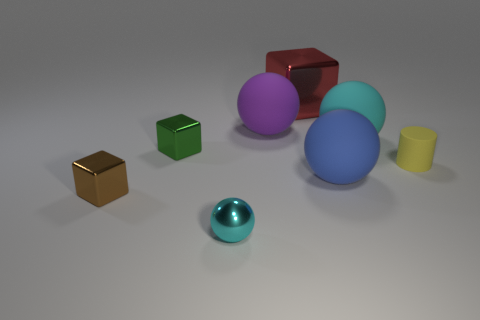Subtract all tiny balls. How many balls are left? 3 Add 2 matte spheres. How many objects exist? 10 Add 6 small cyan metal objects. How many small cyan metal objects are left? 7 Add 6 small blue cubes. How many small blue cubes exist? 6 Subtract all purple balls. How many balls are left? 3 Subtract 1 purple spheres. How many objects are left? 7 Subtract all cylinders. How many objects are left? 7 Subtract 2 blocks. How many blocks are left? 1 Subtract all purple cylinders. Subtract all yellow spheres. How many cylinders are left? 1 Subtract all purple balls. How many purple cylinders are left? 0 